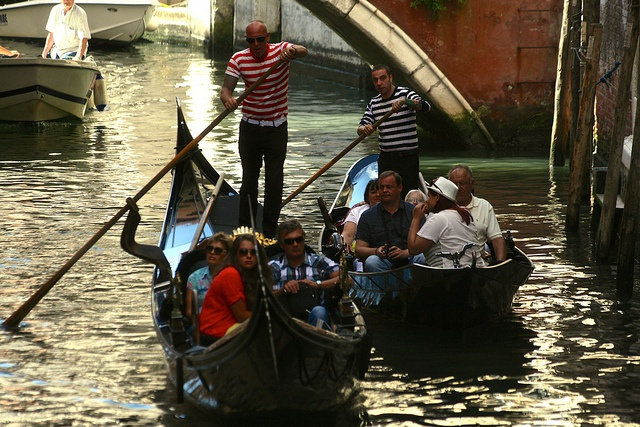Describe the objects in this image and their specific colors. I can see boat in black, gray, and lightblue tones, boat in black, gray, lightblue, and navy tones, people in black, maroon, and gray tones, boat in black, darkgreen, and olive tones, and people in black, maroon, and gray tones in this image. 